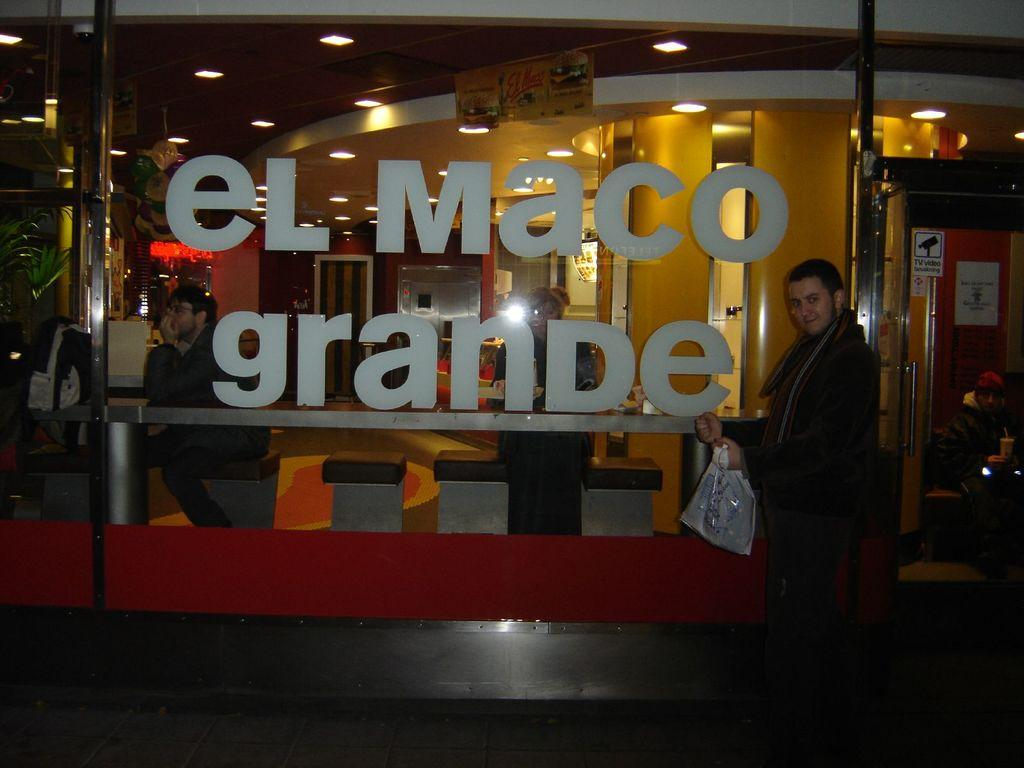What is the person in the image doing? The person is standing in the image and holding a cover. What can be seen on the glass in the image? There is text on a glass in the image. What is visible through the glass in the image? People, chairs, lights, posters, a bag, and pillars are visible through the glass. Is the woman stuck in quicksand in the image? There is no woman or quicksand present in the image. How many trucks can be seen in the image? There are no trucks visible in the image. 